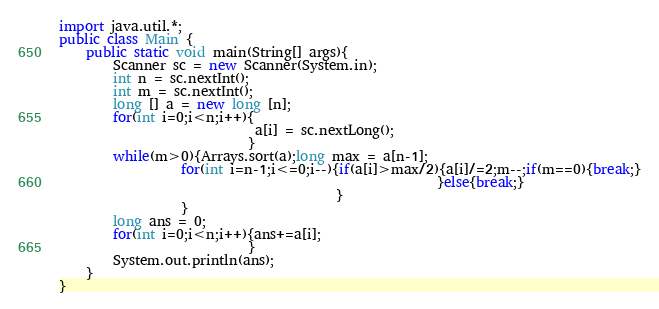Convert code to text. <code><loc_0><loc_0><loc_500><loc_500><_Java_>import java.util.*;
public class Main {
	public static void main(String[] args){
		Scanner sc = new Scanner(System.in);
		int n = sc.nextInt();
        int m = sc.nextInt();
		long [] a = new long [n];
        for(int i=0;i<n;i++){
                             a[i] = sc.nextLong();
                            }        
        while(m>0){Arrays.sort(a);long max = a[n-1];
                  for(int i=n-1;i<=0;i--){if(a[i]>max/2){a[i]/=2;m--;if(m==0){break;}
                                                        }else{break;}
                                         } 
                  }
        long ans = 0;
        for(int i=0;i<n;i++){ans+=a[i];
                            }      
		System.out.println(ans);
	}
}
</code> 